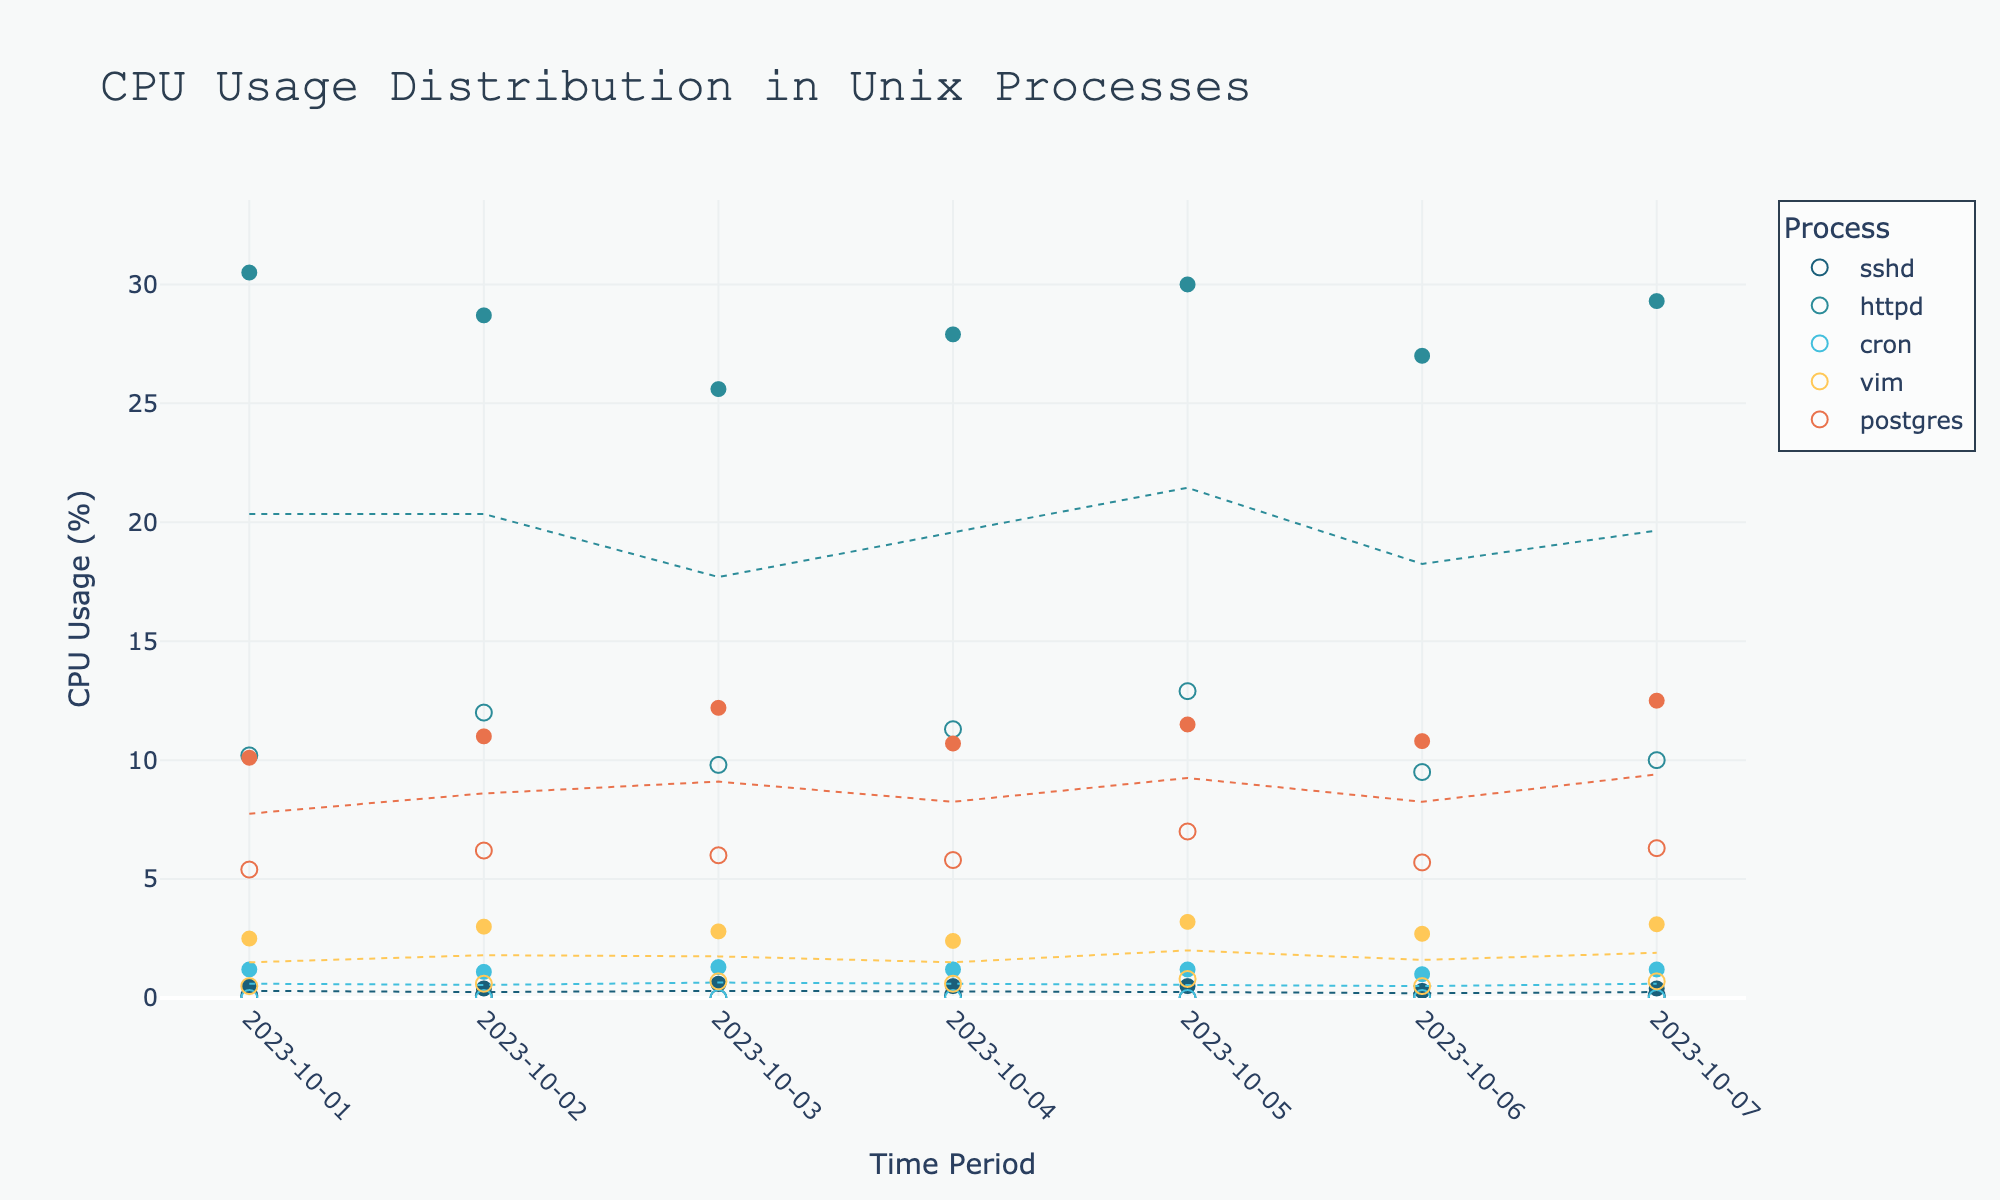What's the title of the figure? The title is usually displayed at the top of the figure. For this specific plot, it's mentioned in the code.
Answer: CPU Usage Distribution in Unix Processes What are the time periods marked on the x-axis? Observing the x-axis, the time periods are marked at regular intervals. In the code, these range from October 1 to October 7, 2023.
Answer: October 1 to October 7, 2023 Which process has the highest maximum CPU usage on October 2nd? Locate the date on the x-axis and observe the markers for different processes. The filled markers represent maximum CPU usage. For October 2nd, the httpd process has the highest maximum CPU usage.
Answer: httpd What's the range of CPU usage for the vim process on October 5th? Find the markers for the vim process on October 5th and observe their vertical positions. The minimum usage is 0.8%, and the maximum is 3.2%. The range is, therefore, the difference between these two values.
Answer: 2.4% Which process consistently has the lowest CPU usage over the entire week? Scan through the entire week's data and observe the minimum CPU usage markers. The cron process consistently shows the lowest values, mostly at 0%.
Answer: cron What's the average maximum CPU usage of the postgres process over the week? Identify the maximum CPU usage markers for the postgres process for each day and find their values. These are 10.1, 11.0, 12.2, 10.7, 11.5, 10.8, and 12.5. Sum them up (10.1 + 11.0 + 12.2 + 10.7 + 11.5 + 10.8 + 12.5 = 78.8) and then divide by the number of days (7).
Answer: 11.26 Compare the range of CPU usages between sshd and vim on October 7th. Which one is wider? For October 7th, observe the range of both sshd and vim by subtracting their minimum values from their maximum values. sshd ranges from 0.1% to 0.4% (0.3% range), and vim ranges from 0.7% to 3.1% (2.4% range). Therefore, vim has a wider range.
Answer: vim Is there any day when the minimum CPU usage of httpd is less than that of postgres? Examine each day's data for httpd and postgres minimum CPU usage values. On all days, httpd's minimum usage (9.5%–12.9%) is greater than postgres's minimum usage (5.4%–7.0%).
Answer: No 